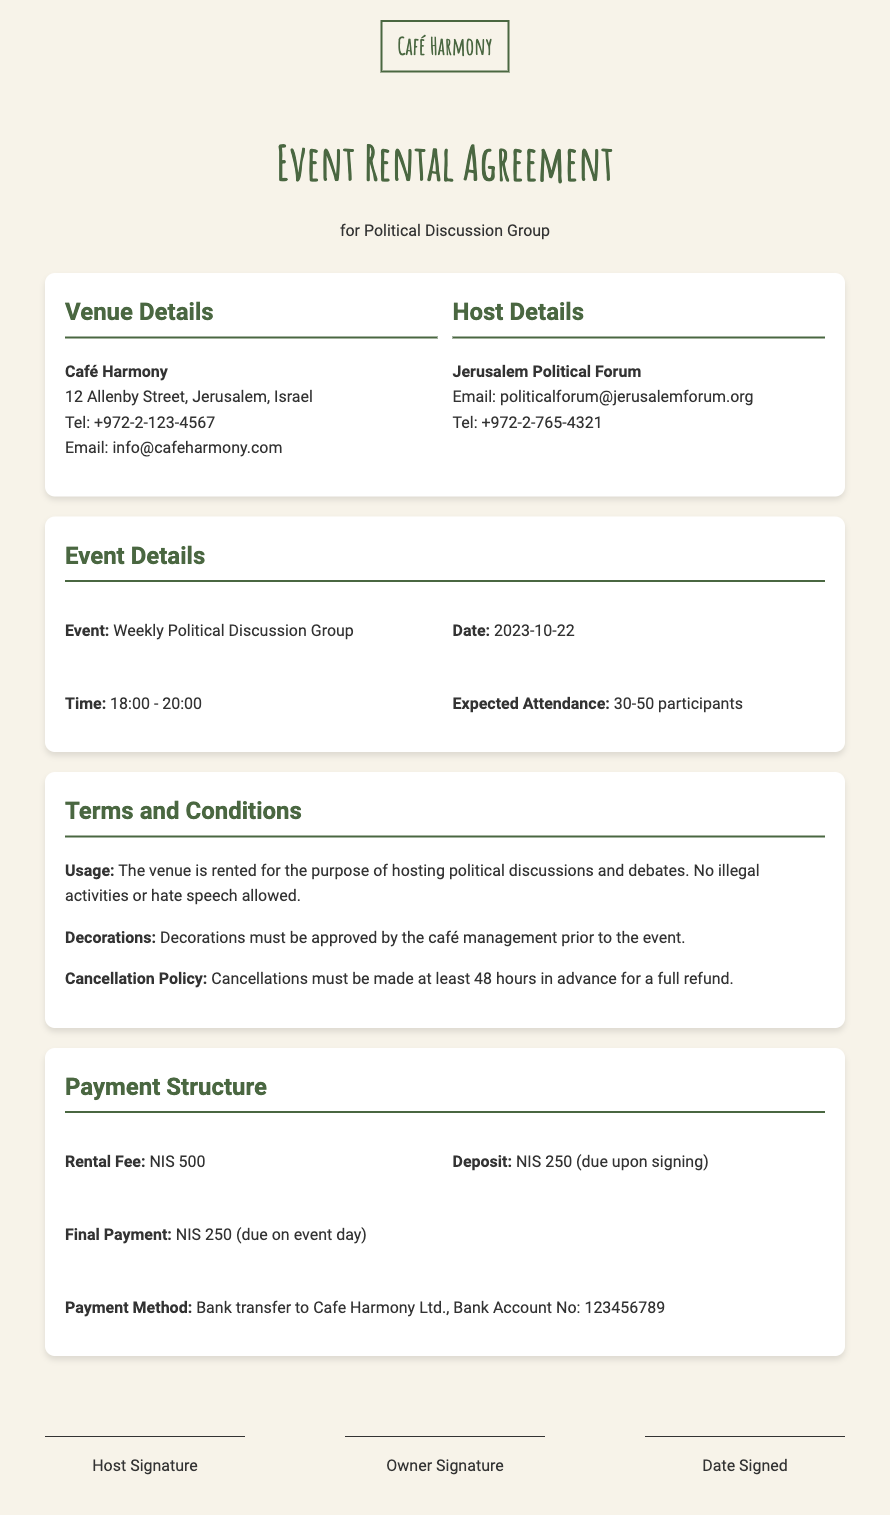what is the rental fee? The rental fee for hosting the event is specified in the payment structure section of the document.
Answer: NIS 500 who is the host of the event? The host is indicated in the host details section of the document, which specifies the organization renting the venue.
Answer: Jerusalem Political Forum what date is the event scheduled for? The date of the event is mentioned directly under the event details section of the document.
Answer: 2023-10-22 what is the cancellation policy? The policy states the conditions under which a booking can be canceled and the refund terms.
Answer: Cancellations must be made at least 48 hours in advance for a full refund what is the deposit amount due upon signing? The deposit amount is outlined in the payment structure section of the document as part of the overall payment plan.
Answer: NIS 250 how many participants are expected to attend? The expected attendance is specified in the event details section which provides a range of participant numbers.
Answer: 30-50 participants what time does the event start? The start time of the event is noted in the event details section, indicating when the discussions will begin.
Answer: 18:00 what is required for decorations? The terms regarding decorations are detailed in the terms and conditions section, specifying the approval process.
Answer: Must be approved by café management 